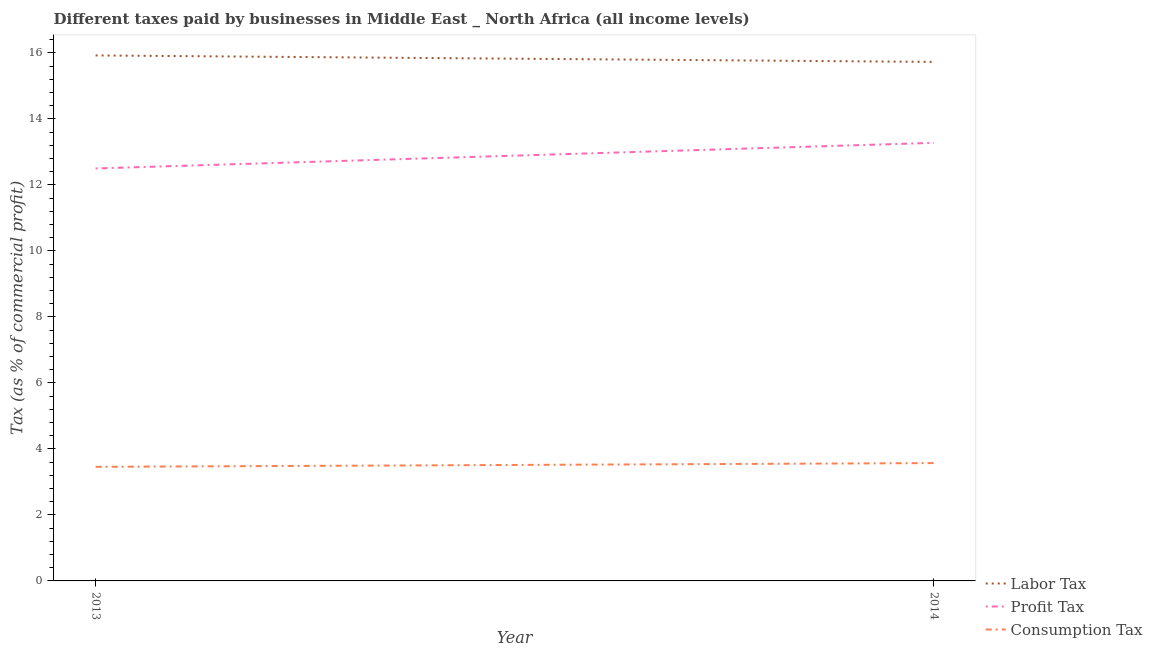Does the line corresponding to percentage of labor tax intersect with the line corresponding to percentage of consumption tax?
Ensure brevity in your answer.  No. What is the percentage of profit tax in 2014?
Give a very brief answer. 13.28. Across all years, what is the maximum percentage of profit tax?
Offer a very short reply. 13.28. Across all years, what is the minimum percentage of consumption tax?
Provide a succinct answer. 3.46. In which year was the percentage of labor tax minimum?
Ensure brevity in your answer.  2014. What is the total percentage of profit tax in the graph?
Provide a succinct answer. 25.78. What is the difference between the percentage of profit tax in 2013 and that in 2014?
Keep it short and to the point. -0.78. What is the difference between the percentage of consumption tax in 2013 and the percentage of labor tax in 2014?
Make the answer very short. -12.27. What is the average percentage of consumption tax per year?
Provide a short and direct response. 3.51. In the year 2014, what is the difference between the percentage of labor tax and percentage of profit tax?
Provide a succinct answer. 2.45. What is the ratio of the percentage of consumption tax in 2013 to that in 2014?
Give a very brief answer. 0.97. In how many years, is the percentage of consumption tax greater than the average percentage of consumption tax taken over all years?
Provide a succinct answer. 1. Does the percentage of labor tax monotonically increase over the years?
Provide a short and direct response. No. How many lines are there?
Offer a terse response. 3. Are the values on the major ticks of Y-axis written in scientific E-notation?
Keep it short and to the point. No. Where does the legend appear in the graph?
Provide a short and direct response. Bottom right. How are the legend labels stacked?
Your answer should be very brief. Vertical. What is the title of the graph?
Keep it short and to the point. Different taxes paid by businesses in Middle East _ North Africa (all income levels). Does "Unemployment benefits" appear as one of the legend labels in the graph?
Provide a short and direct response. No. What is the label or title of the Y-axis?
Make the answer very short. Tax (as % of commercial profit). What is the Tax (as % of commercial profit) in Labor Tax in 2013?
Offer a terse response. 15.93. What is the Tax (as % of commercial profit) of Consumption Tax in 2013?
Give a very brief answer. 3.46. What is the Tax (as % of commercial profit) of Labor Tax in 2014?
Give a very brief answer. 15.73. What is the Tax (as % of commercial profit) in Profit Tax in 2014?
Your response must be concise. 13.28. What is the Tax (as % of commercial profit) in Consumption Tax in 2014?
Provide a short and direct response. 3.57. Across all years, what is the maximum Tax (as % of commercial profit) of Labor Tax?
Make the answer very short. 15.93. Across all years, what is the maximum Tax (as % of commercial profit) in Profit Tax?
Ensure brevity in your answer.  13.28. Across all years, what is the maximum Tax (as % of commercial profit) of Consumption Tax?
Your answer should be very brief. 3.57. Across all years, what is the minimum Tax (as % of commercial profit) of Labor Tax?
Provide a succinct answer. 15.73. Across all years, what is the minimum Tax (as % of commercial profit) in Profit Tax?
Your response must be concise. 12.5. Across all years, what is the minimum Tax (as % of commercial profit) of Consumption Tax?
Keep it short and to the point. 3.46. What is the total Tax (as % of commercial profit) in Labor Tax in the graph?
Provide a short and direct response. 31.65. What is the total Tax (as % of commercial profit) of Profit Tax in the graph?
Offer a very short reply. 25.78. What is the total Tax (as % of commercial profit) of Consumption Tax in the graph?
Offer a terse response. 7.03. What is the difference between the Tax (as % of commercial profit) in Labor Tax in 2013 and that in 2014?
Make the answer very short. 0.2. What is the difference between the Tax (as % of commercial profit) in Profit Tax in 2013 and that in 2014?
Your response must be concise. -0.78. What is the difference between the Tax (as % of commercial profit) in Consumption Tax in 2013 and that in 2014?
Give a very brief answer. -0.11. What is the difference between the Tax (as % of commercial profit) in Labor Tax in 2013 and the Tax (as % of commercial profit) in Profit Tax in 2014?
Provide a short and direct response. 2.65. What is the difference between the Tax (as % of commercial profit) of Labor Tax in 2013 and the Tax (as % of commercial profit) of Consumption Tax in 2014?
Make the answer very short. 12.35. What is the difference between the Tax (as % of commercial profit) in Profit Tax in 2013 and the Tax (as % of commercial profit) in Consumption Tax in 2014?
Provide a short and direct response. 8.93. What is the average Tax (as % of commercial profit) of Labor Tax per year?
Your response must be concise. 15.83. What is the average Tax (as % of commercial profit) in Profit Tax per year?
Make the answer very short. 12.89. What is the average Tax (as % of commercial profit) in Consumption Tax per year?
Provide a succinct answer. 3.51. In the year 2013, what is the difference between the Tax (as % of commercial profit) in Labor Tax and Tax (as % of commercial profit) in Profit Tax?
Offer a very short reply. 3.42. In the year 2013, what is the difference between the Tax (as % of commercial profit) in Labor Tax and Tax (as % of commercial profit) in Consumption Tax?
Your answer should be compact. 12.47. In the year 2013, what is the difference between the Tax (as % of commercial profit) of Profit Tax and Tax (as % of commercial profit) of Consumption Tax?
Offer a very short reply. 9.04. In the year 2014, what is the difference between the Tax (as % of commercial profit) of Labor Tax and Tax (as % of commercial profit) of Profit Tax?
Make the answer very short. 2.45. In the year 2014, what is the difference between the Tax (as % of commercial profit) in Labor Tax and Tax (as % of commercial profit) in Consumption Tax?
Offer a terse response. 12.16. In the year 2014, what is the difference between the Tax (as % of commercial profit) of Profit Tax and Tax (as % of commercial profit) of Consumption Tax?
Provide a succinct answer. 9.7. What is the ratio of the Tax (as % of commercial profit) in Labor Tax in 2013 to that in 2014?
Give a very brief answer. 1.01. What is the ratio of the Tax (as % of commercial profit) in Profit Tax in 2013 to that in 2014?
Provide a succinct answer. 0.94. What is the difference between the highest and the second highest Tax (as % of commercial profit) in Labor Tax?
Provide a succinct answer. 0.2. What is the difference between the highest and the second highest Tax (as % of commercial profit) in Profit Tax?
Provide a succinct answer. 0.78. What is the difference between the highest and the second highest Tax (as % of commercial profit) in Consumption Tax?
Provide a succinct answer. 0.11. What is the difference between the highest and the lowest Tax (as % of commercial profit) in Labor Tax?
Offer a very short reply. 0.2. What is the difference between the highest and the lowest Tax (as % of commercial profit) in Profit Tax?
Your answer should be very brief. 0.78. What is the difference between the highest and the lowest Tax (as % of commercial profit) of Consumption Tax?
Offer a very short reply. 0.11. 